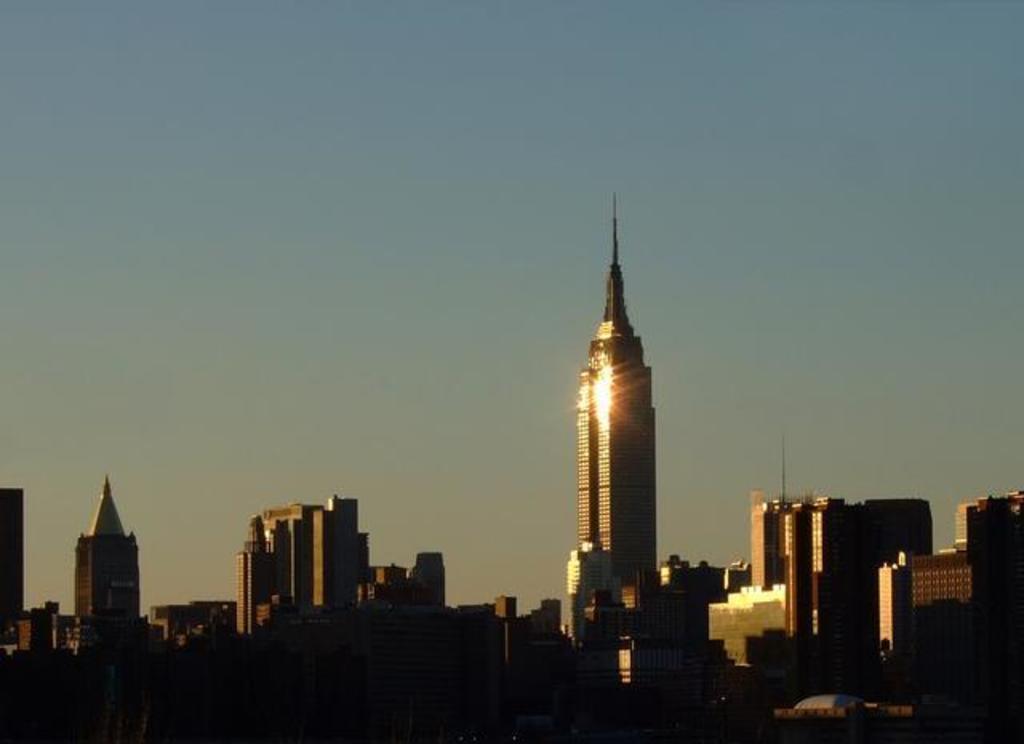How would you summarize this image in a sentence or two? In the picture there are buildings and there is a clear sky. 